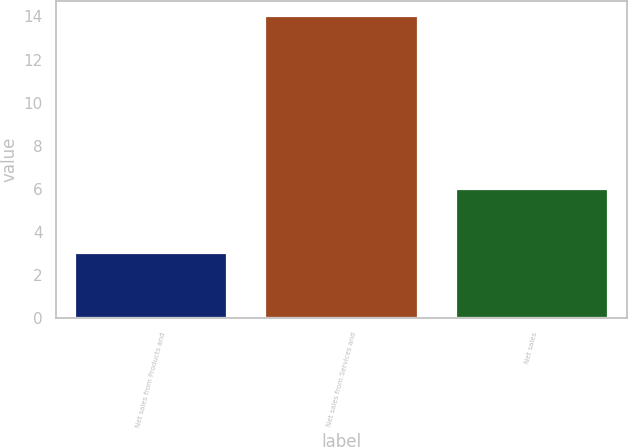Convert chart. <chart><loc_0><loc_0><loc_500><loc_500><bar_chart><fcel>Net sales from Products and<fcel>Net sales from Services and<fcel>Net sales<nl><fcel>3<fcel>14<fcel>6<nl></chart> 